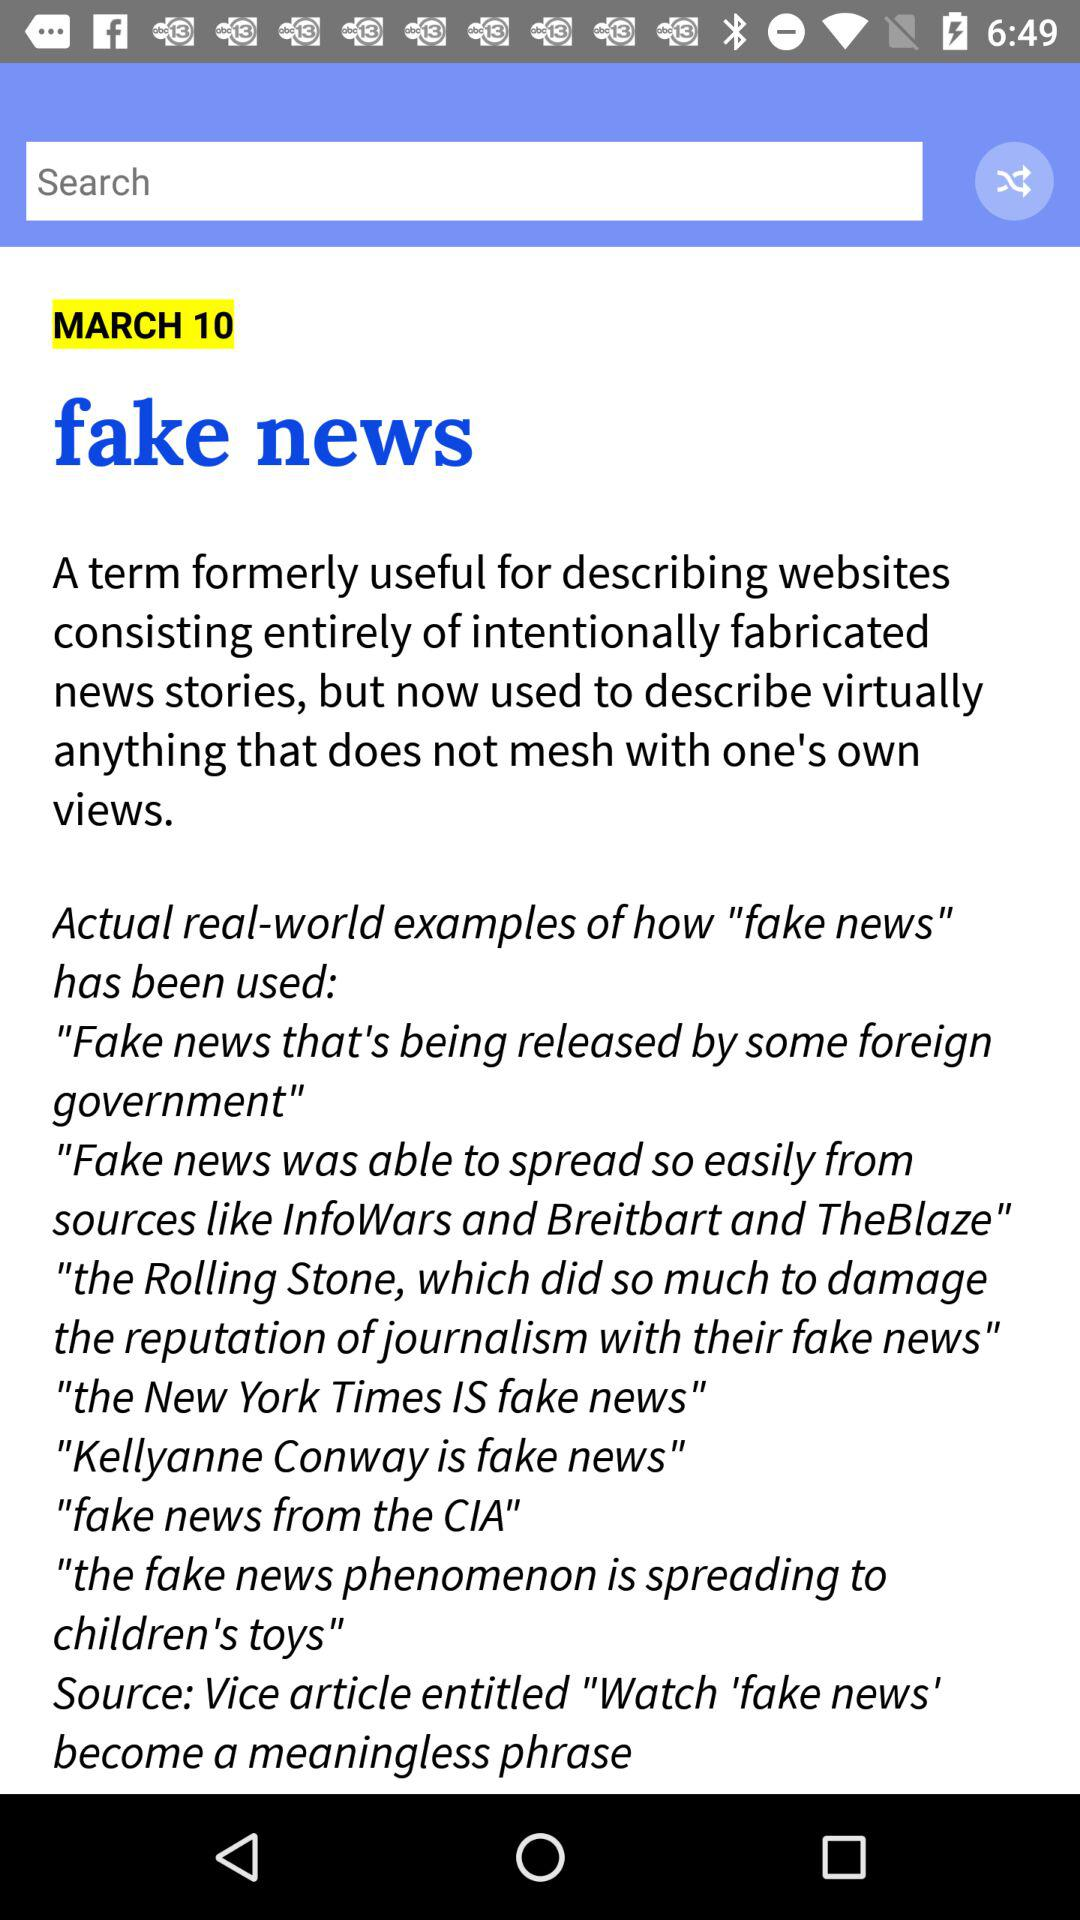What is the published "fake news" date? The published "fake news" date is March 10. 